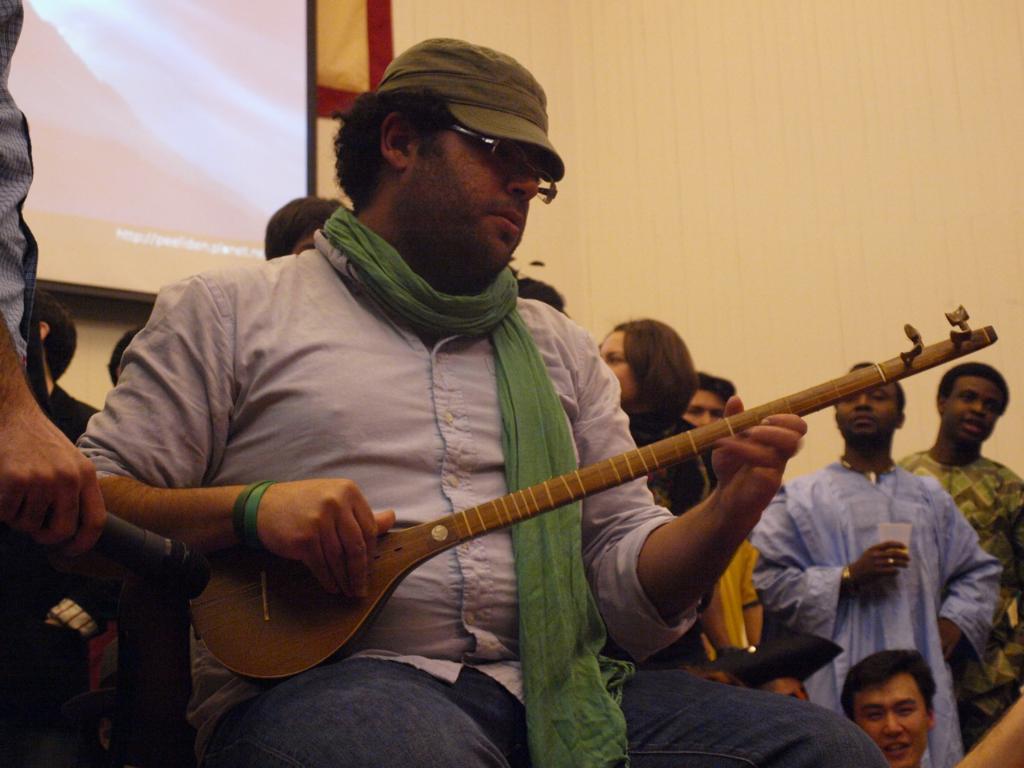Please provide a concise description of this image. In this picture we can see a man sitting and playing a musical instrument, in the background there are some people standing, at the left top there is a screen, we can see a wall on the right side, this man wore a cap, spectacles and a scarf. 